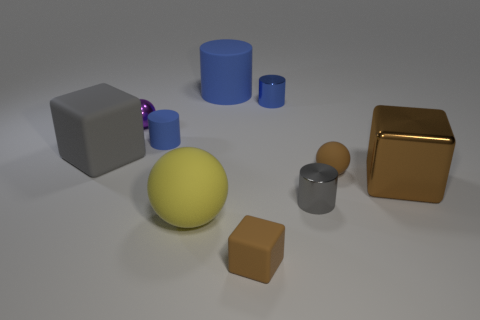Subtract all large balls. How many balls are left? 2 Subtract all gray spheres. How many blue cylinders are left? 3 Subtract 2 cylinders. How many cylinders are left? 2 Subtract all yellow spheres. How many spheres are left? 2 Subtract all green balls. Subtract all brown cylinders. How many balls are left? 3 Subtract all balls. How many objects are left? 7 Add 10 big yellow metallic blocks. How many big yellow metallic blocks exist? 10 Subtract 0 yellow blocks. How many objects are left? 10 Subtract all big cyan shiny balls. Subtract all small gray shiny cylinders. How many objects are left? 9 Add 9 yellow things. How many yellow things are left? 10 